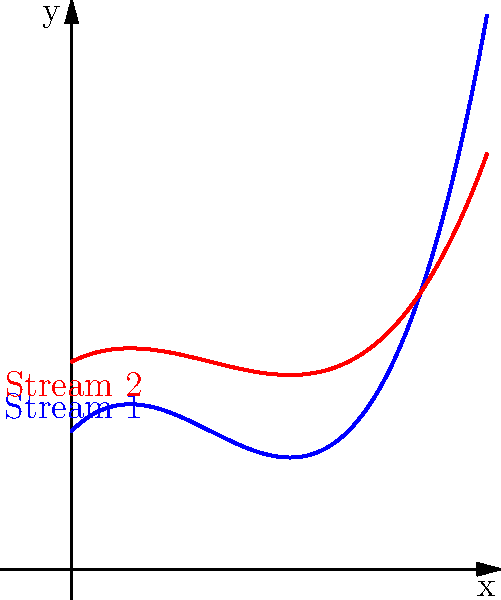In a wetland ecosystem affected by climate change, two streams converge as shown in the streamline visualization above. Stream 1 (blue) has a velocity profile described by $v_1 = 0.5x^3 - 1.5x^2 + x + 1$, while Stream 2 (red) follows $v_2 = 0.25x^3 - 0.75x^2 + 0.5x + 1.5$. At what x-coordinate do these streams have the same velocity, potentially creating a zone of increased pathogen transmission between wildlife populations? To find the x-coordinate where the two streams have the same velocity, we need to solve the equation:

$v_1 = v_2$

Substituting the given velocity profiles:

$0.5x^3 - 1.5x^2 + x + 1 = 0.25x^3 - 0.75x^2 + 0.5x + 1.5$

Simplifying:

$0.25x^3 - 0.75x^2 + 0.5x - 0.5 = 0$

Multiplying all terms by 4 to eliminate fractions:

$x^3 - 3x^2 + 2x - 2 = 0$

This is a cubic equation. We can solve it by factoring:

$(x - 1)(x^2 - 2x + 2) = 0$

Solving this equation:

$x - 1 = 0$ or $x^2 - 2x + 2 = 0$

From the first factor: $x = 1$

The second factor is a quadratic equation with no real roots (discriminant < 0).

Therefore, the only real solution is $x = 1$.
Answer: $x = 1$ 